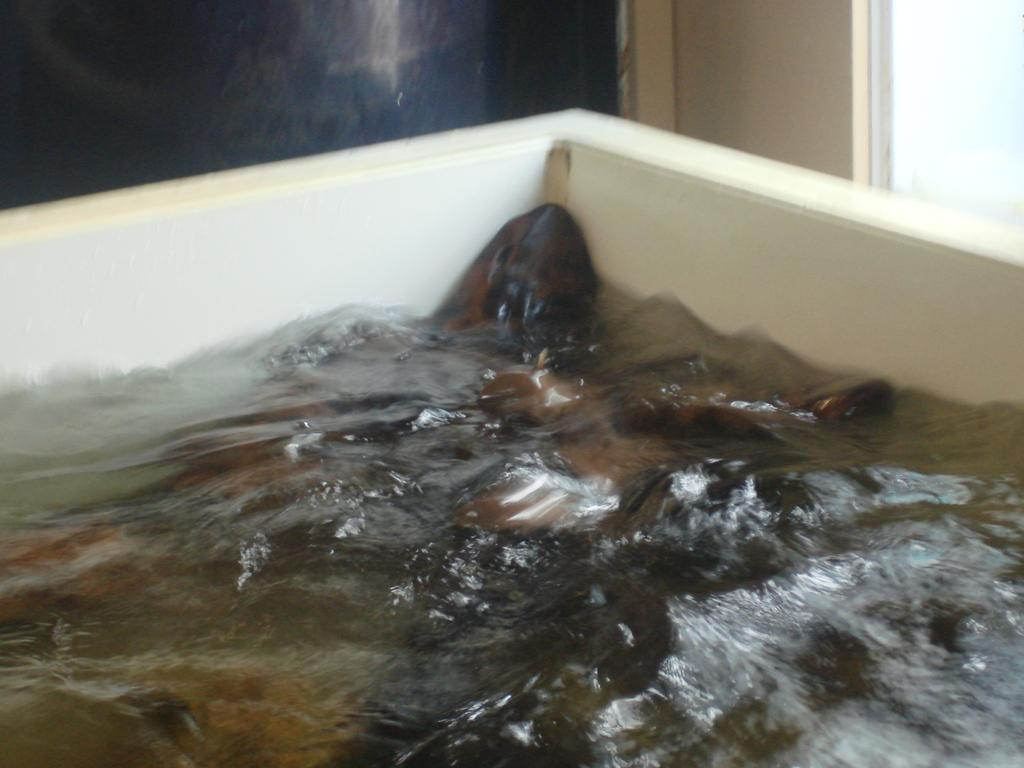What is the main feature in the center of the image? There is a small pond in the center of the image. What is present in the pond? There is water in the pond. What can be seen in the background of the image? There is a wall visible in the background of the image. What type of lock is used to secure the arm in the office in the image? There is no lock, arm, or office present in the image; it features a small pond with water and a wall in the background. 